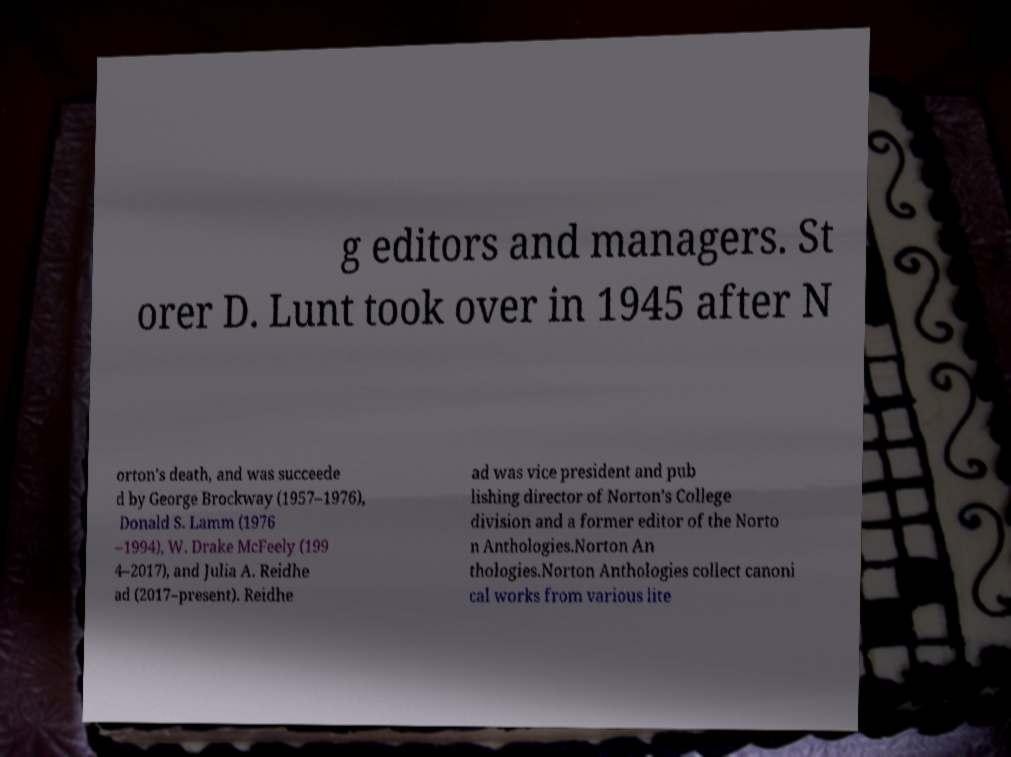Could you assist in decoding the text presented in this image and type it out clearly? g editors and managers. St orer D. Lunt took over in 1945 after N orton's death, and was succeede d by George Brockway (1957–1976), Donald S. Lamm (1976 –1994), W. Drake McFeely (199 4–2017), and Julia A. Reidhe ad (2017–present). Reidhe ad was vice president and pub lishing director of Norton's College division and a former editor of the Norto n Anthologies.Norton An thologies.Norton Anthologies collect canoni cal works from various lite 